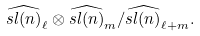Convert formula to latex. <formula><loc_0><loc_0><loc_500><loc_500>\widehat { s l ( n ) } _ { \ell } \otimes \widehat { s l ( n ) } _ { m } / \widehat { s l ( n ) } _ { \ell + m } .</formula> 